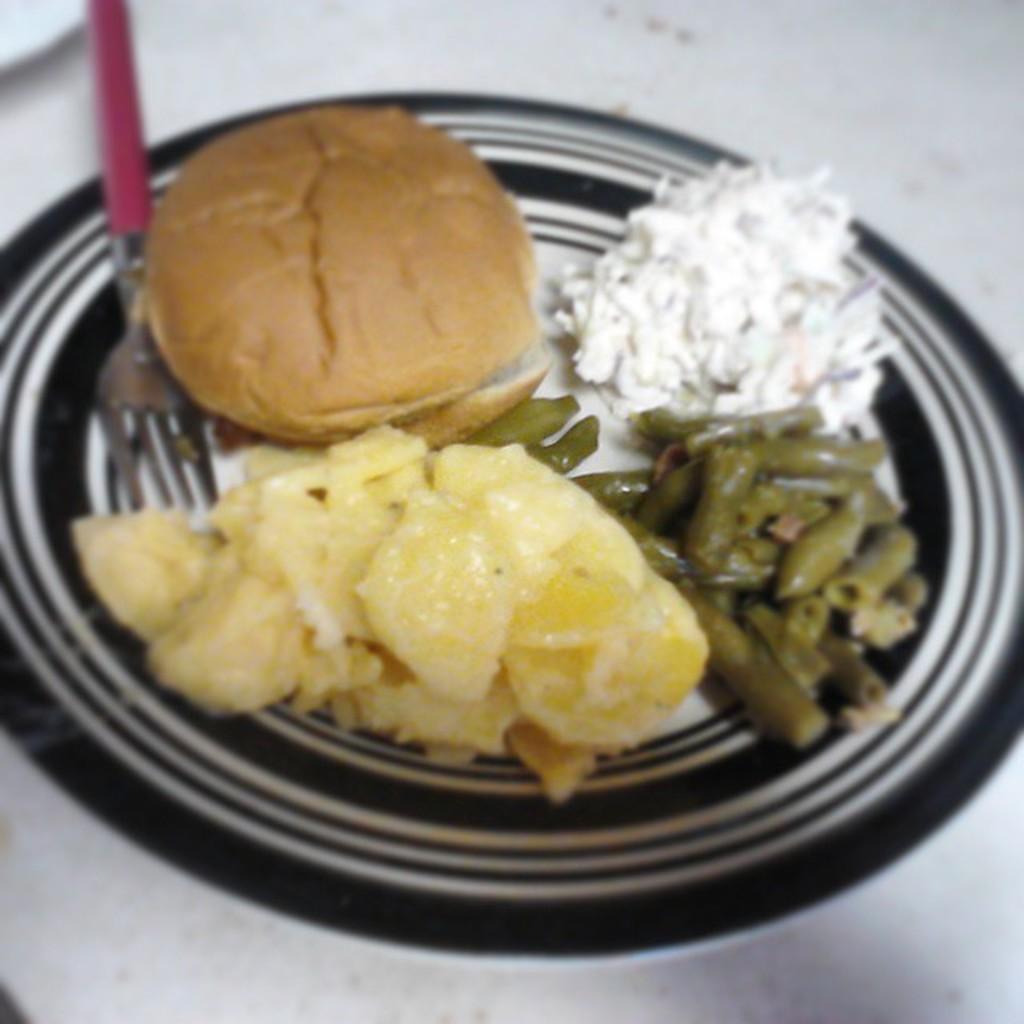Can you describe this image briefly? In this image, there is a white color table, on that table there is a black color plate, in that plate there are some food items kept, there is a fork kept in the plate. 